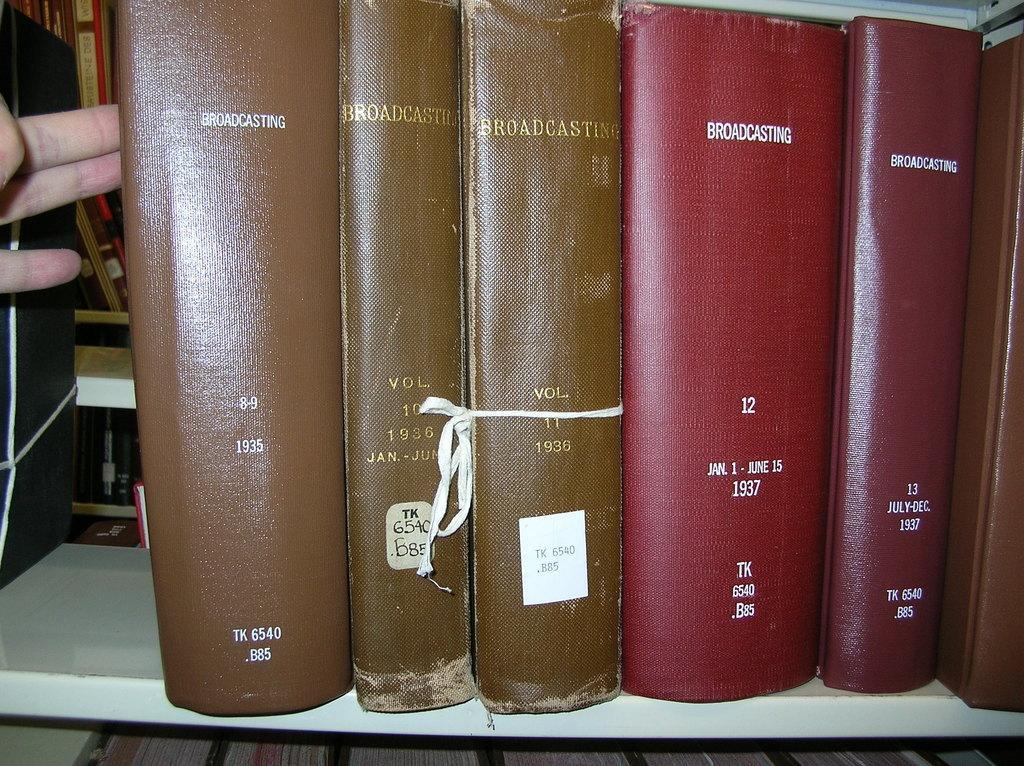Can you describe this image briefly? In this image I can see a human hand touching a book which is brown in color. I can see a white colored rack and in the rack I can see number of books. 